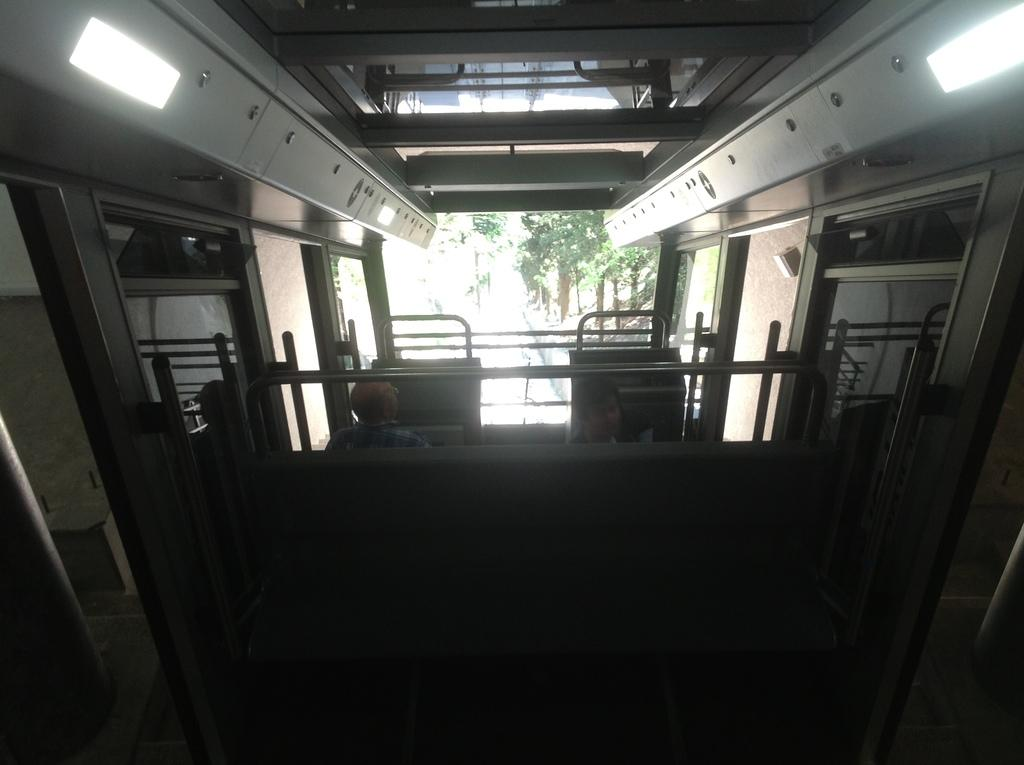How many people are in the image? There are two persons in the center of the image. What can be seen in the background of the image? There are trees in the background of the image. What type of room is visible in the image? There is no room visible in the image; it features two persons and trees in the background. What angle are the persons in the image positioned at? The angle at which the persons are positioned cannot be determined from the image, as it only provides a frontal view of the subjects. 